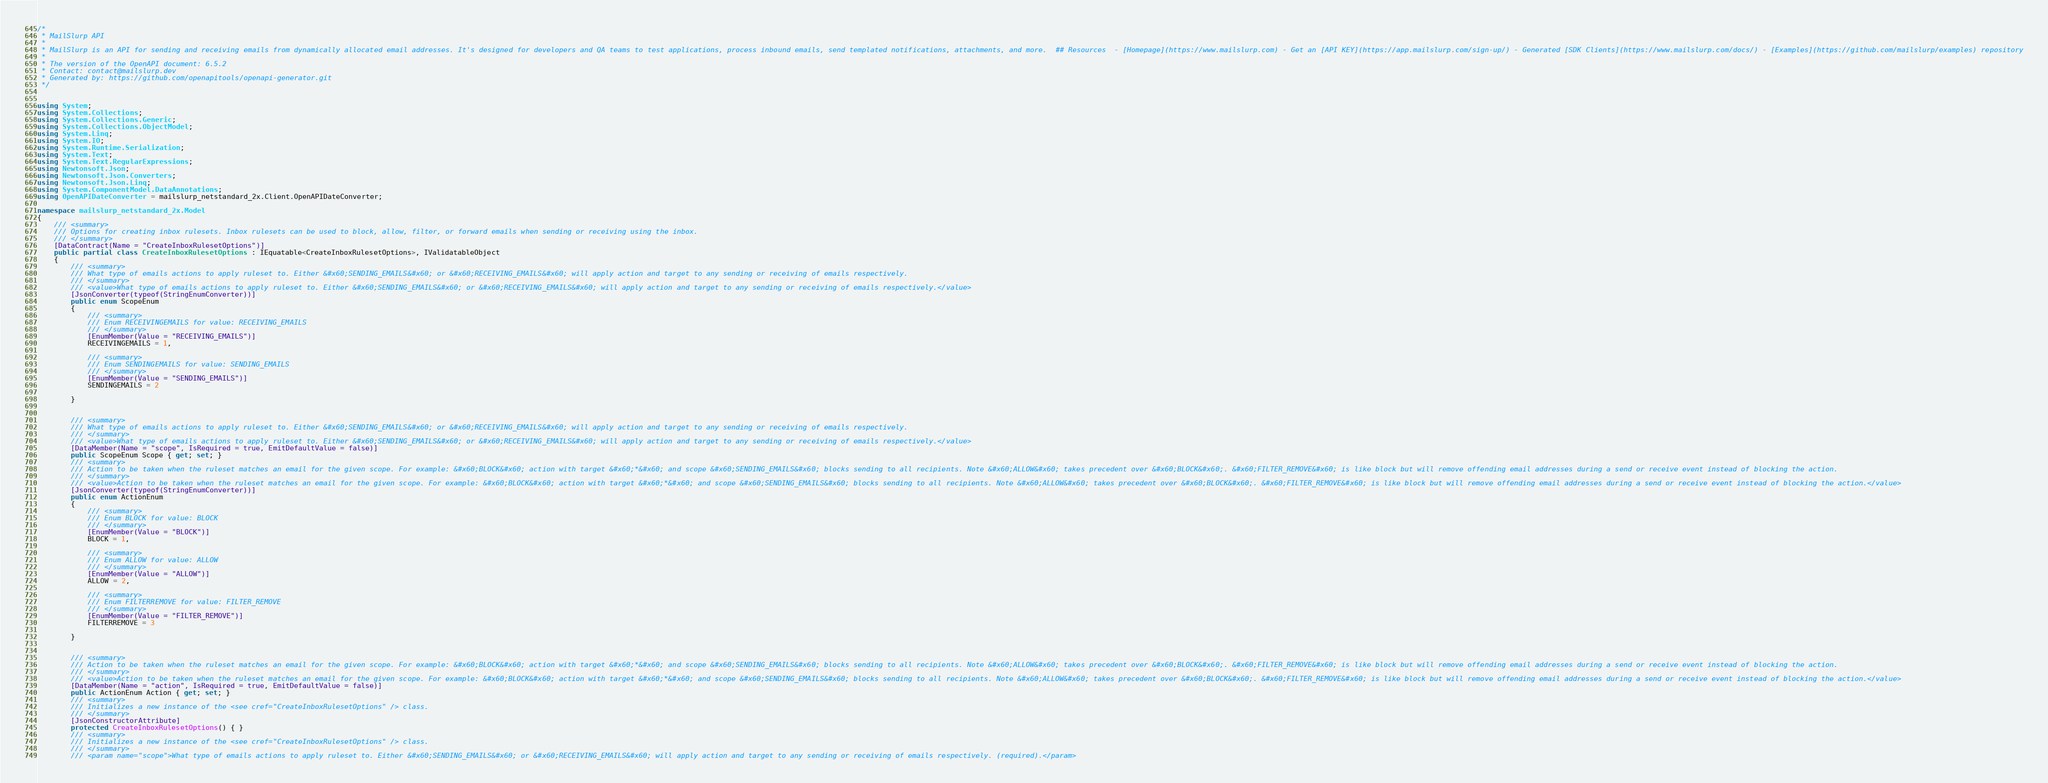<code> <loc_0><loc_0><loc_500><loc_500><_C#_>/*
 * MailSlurp API
 *
 * MailSlurp is an API for sending and receiving emails from dynamically allocated email addresses. It's designed for developers and QA teams to test applications, process inbound emails, send templated notifications, attachments, and more.  ## Resources  - [Homepage](https://www.mailslurp.com) - Get an [API KEY](https://app.mailslurp.com/sign-up/) - Generated [SDK Clients](https://www.mailslurp.com/docs/) - [Examples](https://github.com/mailslurp/examples) repository
 *
 * The version of the OpenAPI document: 6.5.2
 * Contact: contact@mailslurp.dev
 * Generated by: https://github.com/openapitools/openapi-generator.git
 */


using System;
using System.Collections;
using System.Collections.Generic;
using System.Collections.ObjectModel;
using System.Linq;
using System.IO;
using System.Runtime.Serialization;
using System.Text;
using System.Text.RegularExpressions;
using Newtonsoft.Json;
using Newtonsoft.Json.Converters;
using Newtonsoft.Json.Linq;
using System.ComponentModel.DataAnnotations;
using OpenAPIDateConverter = mailslurp_netstandard_2x.Client.OpenAPIDateConverter;

namespace mailslurp_netstandard_2x.Model
{
    /// <summary>
    /// Options for creating inbox rulesets. Inbox rulesets can be used to block, allow, filter, or forward emails when sending or receiving using the inbox.
    /// </summary>
    [DataContract(Name = "CreateInboxRulesetOptions")]
    public partial class CreateInboxRulesetOptions : IEquatable<CreateInboxRulesetOptions>, IValidatableObject
    {
        /// <summary>
        /// What type of emails actions to apply ruleset to. Either &#x60;SENDING_EMAILS&#x60; or &#x60;RECEIVING_EMAILS&#x60; will apply action and target to any sending or receiving of emails respectively.
        /// </summary>
        /// <value>What type of emails actions to apply ruleset to. Either &#x60;SENDING_EMAILS&#x60; or &#x60;RECEIVING_EMAILS&#x60; will apply action and target to any sending or receiving of emails respectively.</value>
        [JsonConverter(typeof(StringEnumConverter))]
        public enum ScopeEnum
        {
            /// <summary>
            /// Enum RECEIVINGEMAILS for value: RECEIVING_EMAILS
            /// </summary>
            [EnumMember(Value = "RECEIVING_EMAILS")]
            RECEIVINGEMAILS = 1,

            /// <summary>
            /// Enum SENDINGEMAILS for value: SENDING_EMAILS
            /// </summary>
            [EnumMember(Value = "SENDING_EMAILS")]
            SENDINGEMAILS = 2

        }


        /// <summary>
        /// What type of emails actions to apply ruleset to. Either &#x60;SENDING_EMAILS&#x60; or &#x60;RECEIVING_EMAILS&#x60; will apply action and target to any sending or receiving of emails respectively.
        /// </summary>
        /// <value>What type of emails actions to apply ruleset to. Either &#x60;SENDING_EMAILS&#x60; or &#x60;RECEIVING_EMAILS&#x60; will apply action and target to any sending or receiving of emails respectively.</value>
        [DataMember(Name = "scope", IsRequired = true, EmitDefaultValue = false)]
        public ScopeEnum Scope { get; set; }
        /// <summary>
        /// Action to be taken when the ruleset matches an email for the given scope. For example: &#x60;BLOCK&#x60; action with target &#x60;*&#x60; and scope &#x60;SENDING_EMAILS&#x60; blocks sending to all recipients. Note &#x60;ALLOW&#x60; takes precedent over &#x60;BLOCK&#x60;. &#x60;FILTER_REMOVE&#x60; is like block but will remove offending email addresses during a send or receive event instead of blocking the action.
        /// </summary>
        /// <value>Action to be taken when the ruleset matches an email for the given scope. For example: &#x60;BLOCK&#x60; action with target &#x60;*&#x60; and scope &#x60;SENDING_EMAILS&#x60; blocks sending to all recipients. Note &#x60;ALLOW&#x60; takes precedent over &#x60;BLOCK&#x60;. &#x60;FILTER_REMOVE&#x60; is like block but will remove offending email addresses during a send or receive event instead of blocking the action.</value>
        [JsonConverter(typeof(StringEnumConverter))]
        public enum ActionEnum
        {
            /// <summary>
            /// Enum BLOCK for value: BLOCK
            /// </summary>
            [EnumMember(Value = "BLOCK")]
            BLOCK = 1,

            /// <summary>
            /// Enum ALLOW for value: ALLOW
            /// </summary>
            [EnumMember(Value = "ALLOW")]
            ALLOW = 2,

            /// <summary>
            /// Enum FILTERREMOVE for value: FILTER_REMOVE
            /// </summary>
            [EnumMember(Value = "FILTER_REMOVE")]
            FILTERREMOVE = 3

        }


        /// <summary>
        /// Action to be taken when the ruleset matches an email for the given scope. For example: &#x60;BLOCK&#x60; action with target &#x60;*&#x60; and scope &#x60;SENDING_EMAILS&#x60; blocks sending to all recipients. Note &#x60;ALLOW&#x60; takes precedent over &#x60;BLOCK&#x60;. &#x60;FILTER_REMOVE&#x60; is like block but will remove offending email addresses during a send or receive event instead of blocking the action.
        /// </summary>
        /// <value>Action to be taken when the ruleset matches an email for the given scope. For example: &#x60;BLOCK&#x60; action with target &#x60;*&#x60; and scope &#x60;SENDING_EMAILS&#x60; blocks sending to all recipients. Note &#x60;ALLOW&#x60; takes precedent over &#x60;BLOCK&#x60;. &#x60;FILTER_REMOVE&#x60; is like block but will remove offending email addresses during a send or receive event instead of blocking the action.</value>
        [DataMember(Name = "action", IsRequired = true, EmitDefaultValue = false)]
        public ActionEnum Action { get; set; }
        /// <summary>
        /// Initializes a new instance of the <see cref="CreateInboxRulesetOptions" /> class.
        /// </summary>
        [JsonConstructorAttribute]
        protected CreateInboxRulesetOptions() { }
        /// <summary>
        /// Initializes a new instance of the <see cref="CreateInboxRulesetOptions" /> class.
        /// </summary>
        /// <param name="scope">What type of emails actions to apply ruleset to. Either &#x60;SENDING_EMAILS&#x60; or &#x60;RECEIVING_EMAILS&#x60; will apply action and target to any sending or receiving of emails respectively. (required).</param></code> 